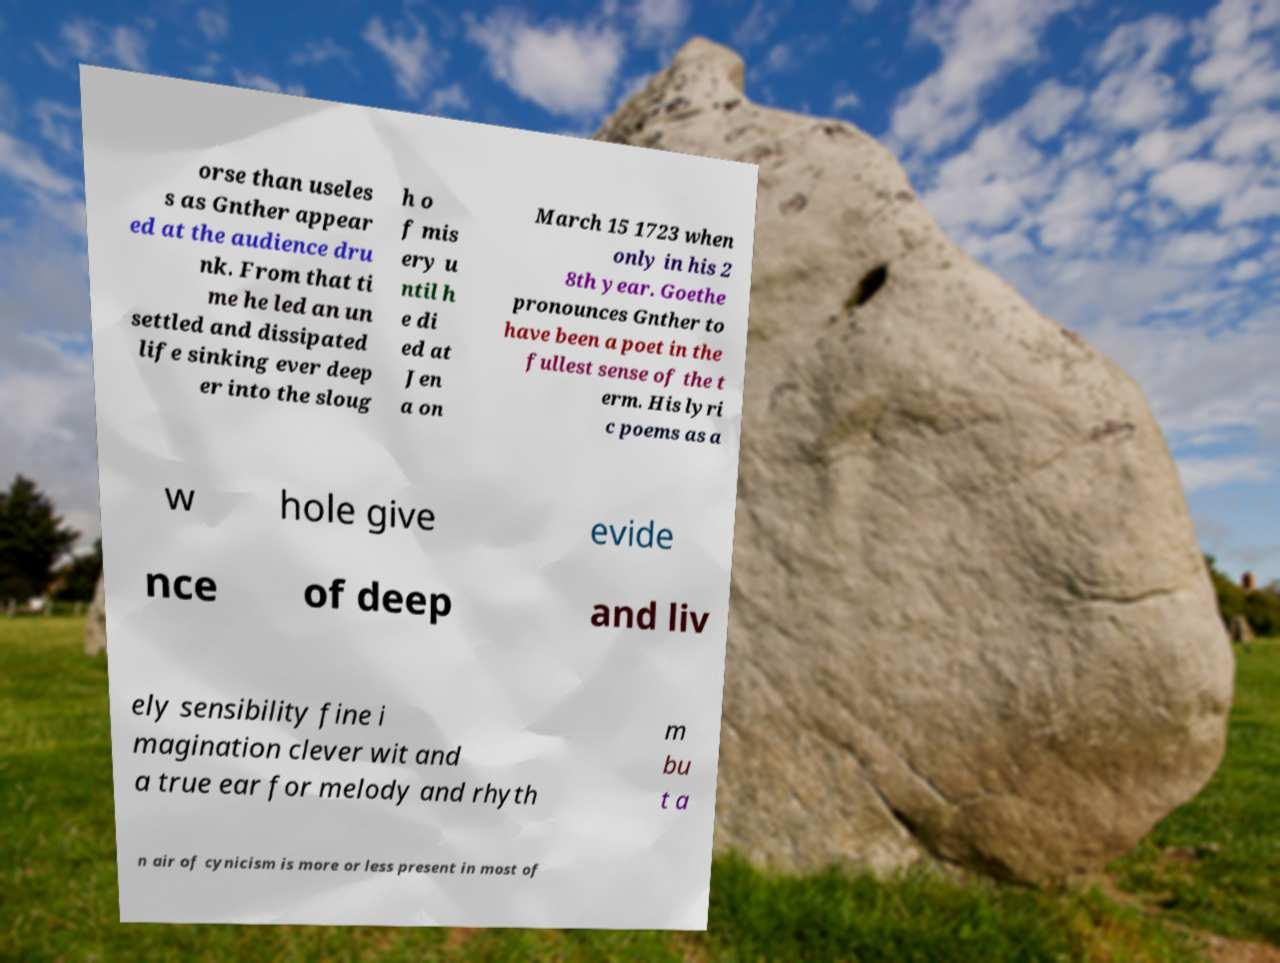There's text embedded in this image that I need extracted. Can you transcribe it verbatim? orse than useles s as Gnther appear ed at the audience dru nk. From that ti me he led an un settled and dissipated life sinking ever deep er into the sloug h o f mis ery u ntil h e di ed at Jen a on March 15 1723 when only in his 2 8th year. Goethe pronounces Gnther to have been a poet in the fullest sense of the t erm. His lyri c poems as a w hole give evide nce of deep and liv ely sensibility fine i magination clever wit and a true ear for melody and rhyth m bu t a n air of cynicism is more or less present in most of 